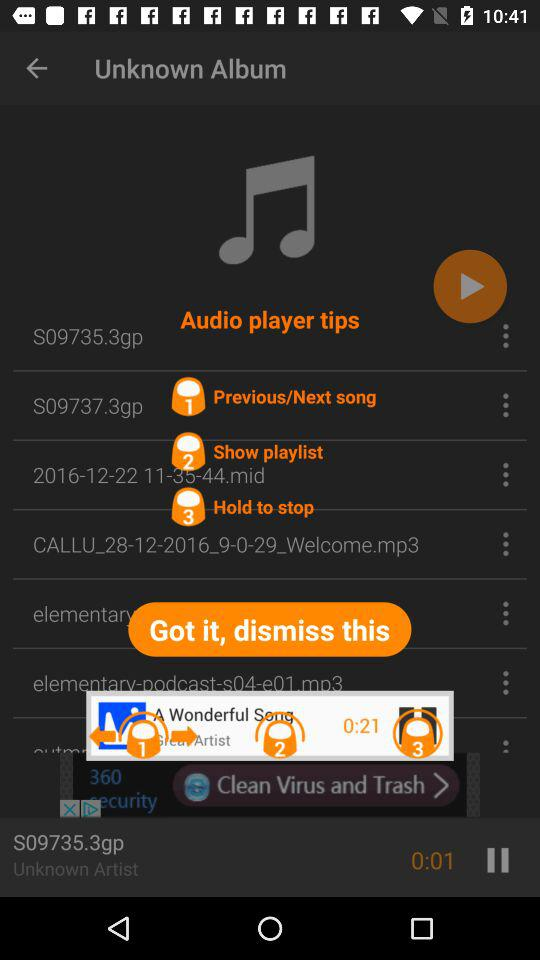What is the name of the current playing song? The name of the current playing song is "S09735.3gp". 